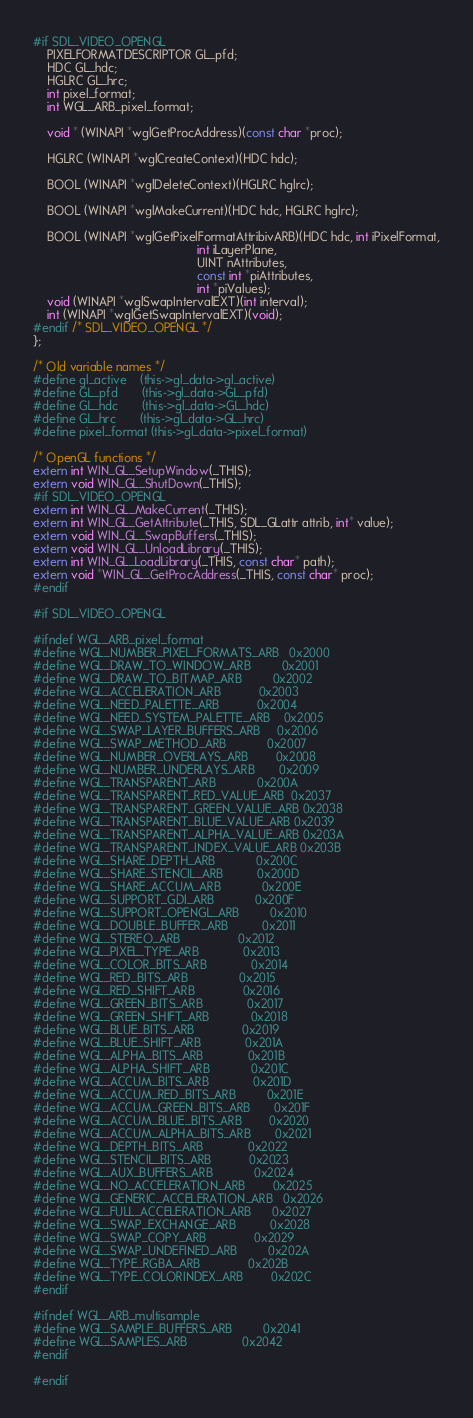Convert code to text. <code><loc_0><loc_0><loc_500><loc_500><_C_>
#if SDL_VIDEO_OPENGL
    PIXELFORMATDESCRIPTOR GL_pfd;
    HDC GL_hdc;
    HGLRC GL_hrc;
    int pixel_format;
    int WGL_ARB_pixel_format;

    void * (WINAPI *wglGetProcAddress)(const char *proc);

    HGLRC (WINAPI *wglCreateContext)(HDC hdc);

    BOOL (WINAPI *wglDeleteContext)(HGLRC hglrc);

    BOOL (WINAPI *wglMakeCurrent)(HDC hdc, HGLRC hglrc);
   
    BOOL (WINAPI *wglGetPixelFormatAttribivARB)(HDC hdc, int iPixelFormat,
                                                int iLayerPlane,
                                                UINT nAttributes, 
                                                const int *piAttributes,
                                                int *piValues);
    void (WINAPI *wglSwapIntervalEXT)(int interval);
    int (WINAPI *wglGetSwapIntervalEXT)(void);
#endif /* SDL_VIDEO_OPENGL */
};

/* Old variable names */
#define gl_active	(this->gl_data->gl_active)
#define GL_pfd		(this->gl_data->GL_pfd)
#define GL_hdc		(this->gl_data->GL_hdc)
#define GL_hrc		(this->gl_data->GL_hrc)
#define pixel_format	(this->gl_data->pixel_format)

/* OpenGL functions */
extern int WIN_GL_SetupWindow(_THIS);
extern void WIN_GL_ShutDown(_THIS);
#if SDL_VIDEO_OPENGL
extern int WIN_GL_MakeCurrent(_THIS);
extern int WIN_GL_GetAttribute(_THIS, SDL_GLattr attrib, int* value);
extern void WIN_GL_SwapBuffers(_THIS);
extern void WIN_GL_UnloadLibrary(_THIS);
extern int WIN_GL_LoadLibrary(_THIS, const char* path);
extern void *WIN_GL_GetProcAddress(_THIS, const char* proc);
#endif

#if SDL_VIDEO_OPENGL

#ifndef WGL_ARB_pixel_format
#define WGL_NUMBER_PIXEL_FORMATS_ARB   0x2000
#define WGL_DRAW_TO_WINDOW_ARB         0x2001
#define WGL_DRAW_TO_BITMAP_ARB         0x2002
#define WGL_ACCELERATION_ARB           0x2003
#define WGL_NEED_PALETTE_ARB           0x2004
#define WGL_NEED_SYSTEM_PALETTE_ARB    0x2005
#define WGL_SWAP_LAYER_BUFFERS_ARB     0x2006
#define WGL_SWAP_METHOD_ARB            0x2007
#define WGL_NUMBER_OVERLAYS_ARB        0x2008
#define WGL_NUMBER_UNDERLAYS_ARB       0x2009
#define WGL_TRANSPARENT_ARB            0x200A
#define WGL_TRANSPARENT_RED_VALUE_ARB  0x2037
#define WGL_TRANSPARENT_GREEN_VALUE_ARB 0x2038
#define WGL_TRANSPARENT_BLUE_VALUE_ARB 0x2039
#define WGL_TRANSPARENT_ALPHA_VALUE_ARB 0x203A
#define WGL_TRANSPARENT_INDEX_VALUE_ARB 0x203B
#define WGL_SHARE_DEPTH_ARB            0x200C
#define WGL_SHARE_STENCIL_ARB          0x200D
#define WGL_SHARE_ACCUM_ARB            0x200E
#define WGL_SUPPORT_GDI_ARB            0x200F
#define WGL_SUPPORT_OPENGL_ARB         0x2010
#define WGL_DOUBLE_BUFFER_ARB          0x2011
#define WGL_STEREO_ARB                 0x2012
#define WGL_PIXEL_TYPE_ARB             0x2013
#define WGL_COLOR_BITS_ARB             0x2014
#define WGL_RED_BITS_ARB               0x2015
#define WGL_RED_SHIFT_ARB              0x2016
#define WGL_GREEN_BITS_ARB             0x2017
#define WGL_GREEN_SHIFT_ARB            0x2018
#define WGL_BLUE_BITS_ARB              0x2019
#define WGL_BLUE_SHIFT_ARB             0x201A
#define WGL_ALPHA_BITS_ARB             0x201B
#define WGL_ALPHA_SHIFT_ARB            0x201C
#define WGL_ACCUM_BITS_ARB             0x201D
#define WGL_ACCUM_RED_BITS_ARB         0x201E
#define WGL_ACCUM_GREEN_BITS_ARB       0x201F
#define WGL_ACCUM_BLUE_BITS_ARB        0x2020
#define WGL_ACCUM_ALPHA_BITS_ARB       0x2021
#define WGL_DEPTH_BITS_ARB             0x2022
#define WGL_STENCIL_BITS_ARB           0x2023
#define WGL_AUX_BUFFERS_ARB            0x2024
#define WGL_NO_ACCELERATION_ARB        0x2025
#define WGL_GENERIC_ACCELERATION_ARB   0x2026
#define WGL_FULL_ACCELERATION_ARB      0x2027
#define WGL_SWAP_EXCHANGE_ARB          0x2028
#define WGL_SWAP_COPY_ARB              0x2029
#define WGL_SWAP_UNDEFINED_ARB         0x202A
#define WGL_TYPE_RGBA_ARB              0x202B
#define WGL_TYPE_COLORINDEX_ARB        0x202C
#endif

#ifndef WGL_ARB_multisample
#define WGL_SAMPLE_BUFFERS_ARB         0x2041
#define WGL_SAMPLES_ARB                0x2042
#endif

#endif
</code> 